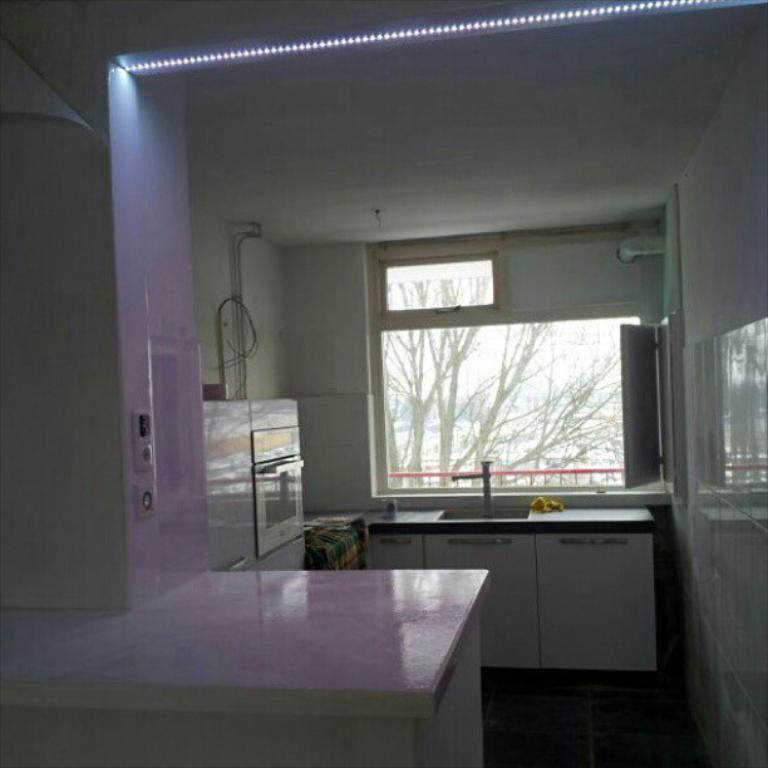Can you describe this image briefly? In this image, we can see a kitchen. There is a counter top at the bottom of the image. There is a window and micro oven in the middle of the image. There is a ceiling and some lights at the top of the image. 